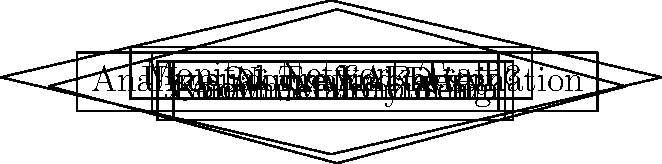In a network traffic analysis system designed to detect suspicious activities, at which stage would you first identify a potential threat from a known malicious IP address? To identify a potential threat from a known malicious IP address, we need to follow the flow chart step-by-step:

1. Start by monitoring network traffic (top block).
2. The system checks for unusual traffic patterns (first diamond).
3. If an unusual pattern is detected (Yes), we move to "Analyze Source and Destination" (right rectangle).
4. After analysis, we reach the "Known Malicious IP?" decision point (second diamond).
5. Here, the system checks if the IP address matches any known malicious IPs in its database.
6. If it's a known malicious IP (Yes), an alert is sent to the security team.

The stage where we first identify a potential threat from a known malicious IP is at the "Known Malicious IP?" decision point. This is where the system compares the IP addresses involved in the unusual traffic against a database of known malicious IPs.
Answer: "Known Malicious IP?" decision point 